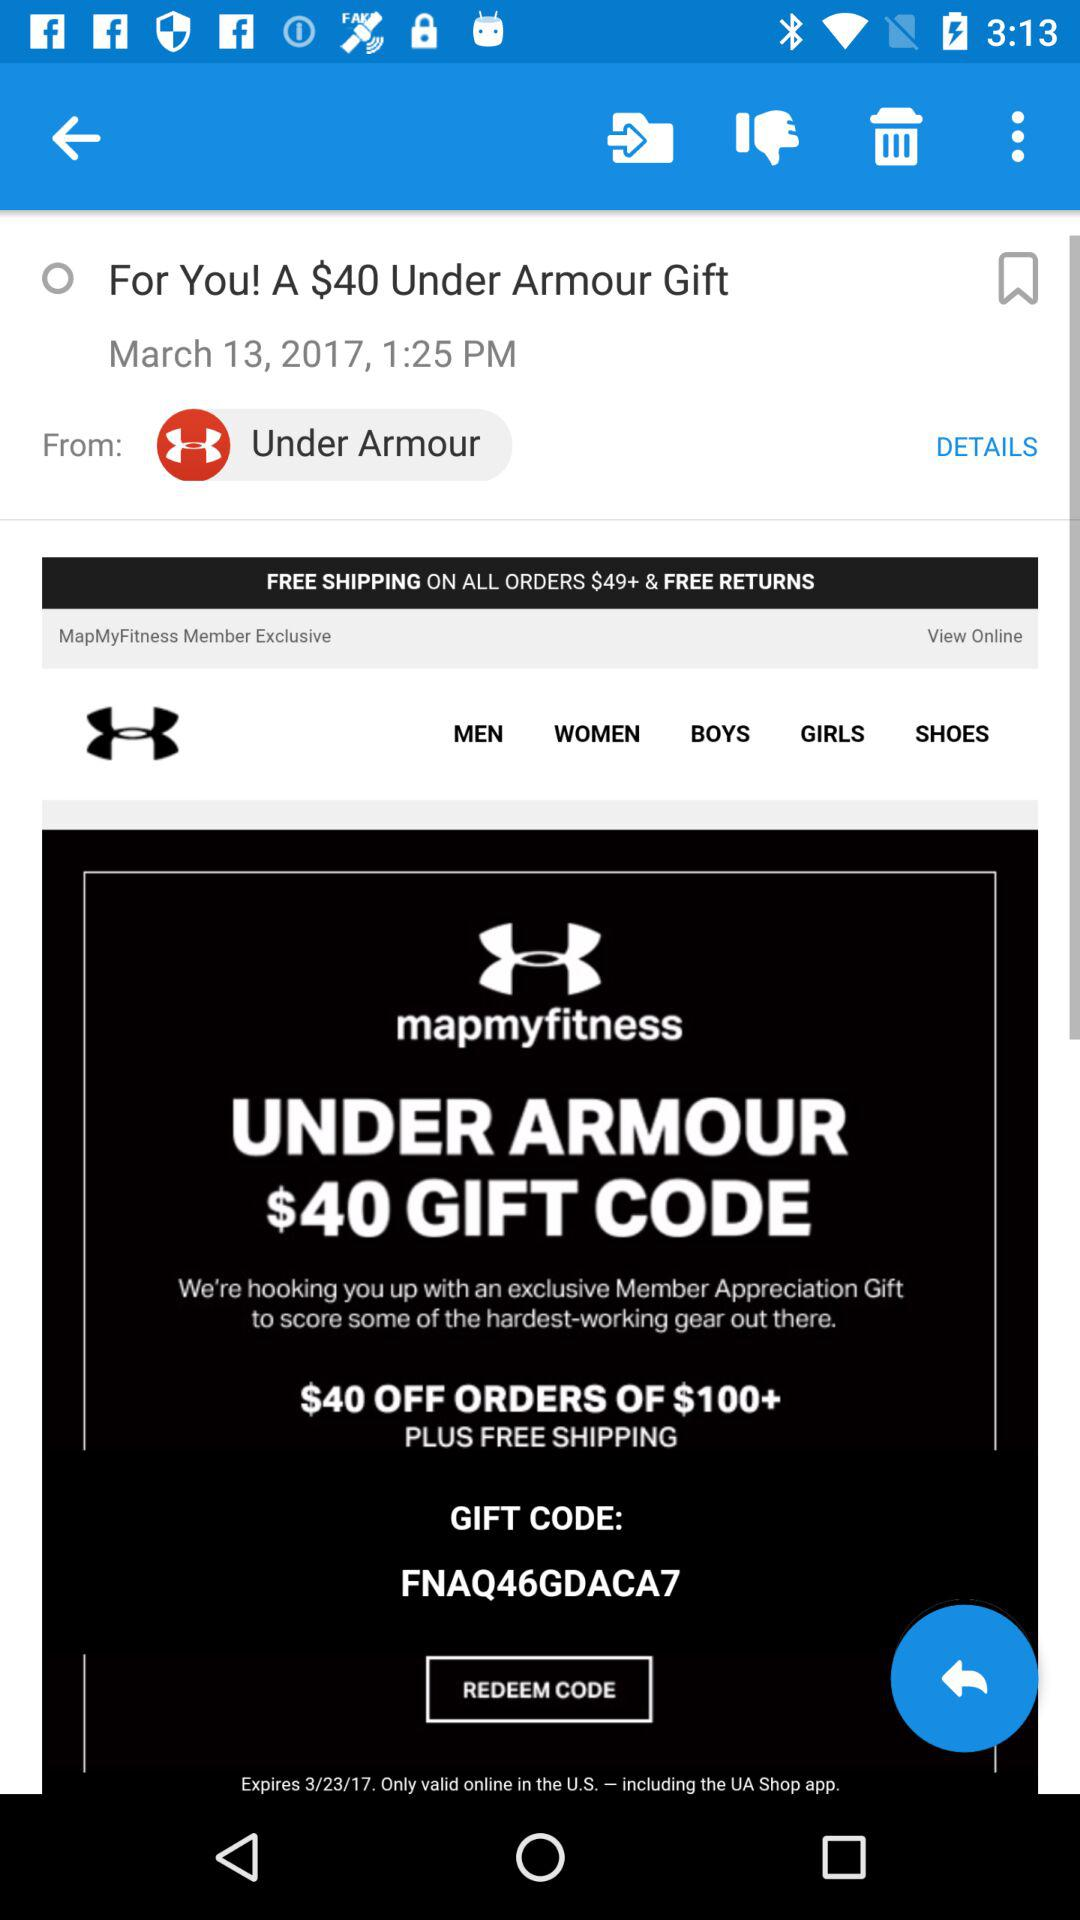What is the expiration date of the gift code?
Answer the question using a single word or phrase. 3/23/17 